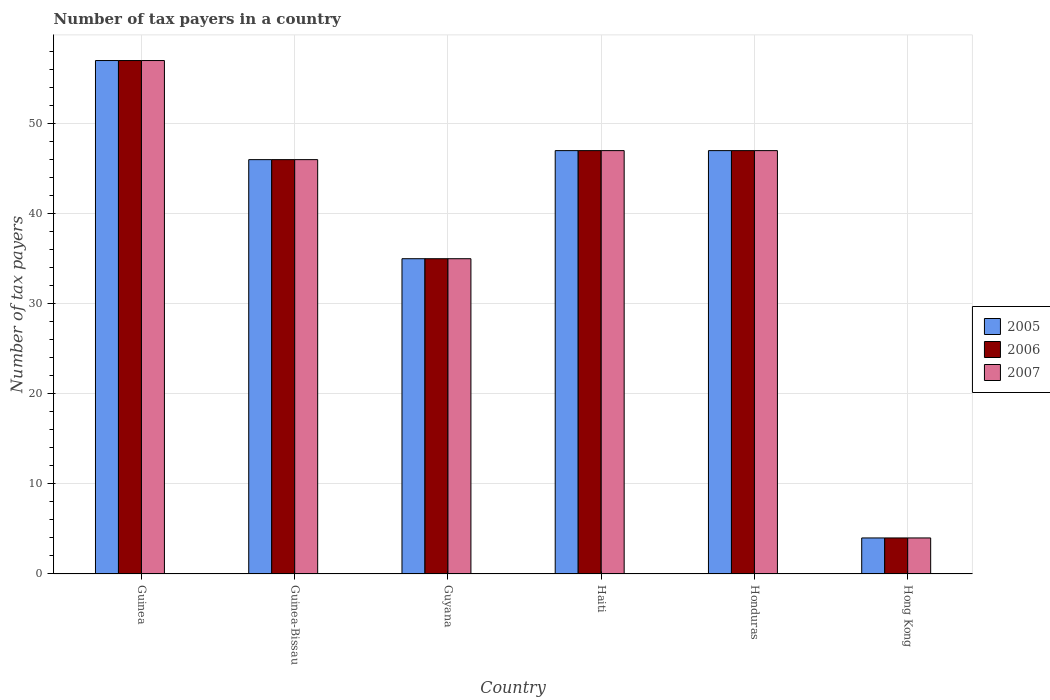Are the number of bars per tick equal to the number of legend labels?
Provide a succinct answer. Yes. Are the number of bars on each tick of the X-axis equal?
Provide a succinct answer. Yes. How many bars are there on the 2nd tick from the left?
Your answer should be compact. 3. How many bars are there on the 5th tick from the right?
Your answer should be compact. 3. What is the label of the 4th group of bars from the left?
Keep it short and to the point. Haiti. In which country was the number of tax payers in in 2007 maximum?
Keep it short and to the point. Guinea. In which country was the number of tax payers in in 2007 minimum?
Your response must be concise. Hong Kong. What is the total number of tax payers in in 2006 in the graph?
Give a very brief answer. 236. What is the difference between the number of tax payers in in 2006 in Honduras and that in Hong Kong?
Keep it short and to the point. 43. What is the difference between the number of tax payers in in 2006 in Honduras and the number of tax payers in in 2007 in Guyana?
Offer a terse response. 12. What is the average number of tax payers in in 2005 per country?
Your answer should be very brief. 39.33. What is the ratio of the number of tax payers in in 2007 in Guinea-Bissau to that in Haiti?
Your answer should be compact. 0.98. Is the number of tax payers in in 2005 in Guinea less than that in Hong Kong?
Ensure brevity in your answer.  No. Is the difference between the number of tax payers in in 2006 in Honduras and Hong Kong greater than the difference between the number of tax payers in in 2007 in Honduras and Hong Kong?
Provide a succinct answer. No. What is the difference between the highest and the lowest number of tax payers in in 2007?
Offer a very short reply. 53. Is the sum of the number of tax payers in in 2005 in Haiti and Honduras greater than the maximum number of tax payers in in 2007 across all countries?
Provide a succinct answer. Yes. What does the 2nd bar from the right in Hong Kong represents?
Ensure brevity in your answer.  2006. Is it the case that in every country, the sum of the number of tax payers in in 2006 and number of tax payers in in 2005 is greater than the number of tax payers in in 2007?
Your answer should be very brief. Yes. Are all the bars in the graph horizontal?
Offer a very short reply. No. How many countries are there in the graph?
Ensure brevity in your answer.  6. Are the values on the major ticks of Y-axis written in scientific E-notation?
Provide a short and direct response. No. Does the graph contain any zero values?
Offer a very short reply. No. Where does the legend appear in the graph?
Ensure brevity in your answer.  Center right. How are the legend labels stacked?
Ensure brevity in your answer.  Vertical. What is the title of the graph?
Your answer should be very brief. Number of tax payers in a country. What is the label or title of the Y-axis?
Offer a terse response. Number of tax payers. What is the Number of tax payers in 2006 in Guinea?
Make the answer very short. 57. What is the Number of tax payers in 2007 in Guinea?
Provide a succinct answer. 57. What is the Number of tax payers in 2005 in Guinea-Bissau?
Provide a short and direct response. 46. What is the Number of tax payers in 2006 in Guyana?
Ensure brevity in your answer.  35. What is the Number of tax payers of 2006 in Haiti?
Offer a very short reply. 47. What is the Number of tax payers of 2007 in Haiti?
Ensure brevity in your answer.  47. What is the Number of tax payers of 2005 in Honduras?
Offer a very short reply. 47. What is the Number of tax payers of 2006 in Honduras?
Your answer should be compact. 47. What is the Number of tax payers in 2007 in Honduras?
Ensure brevity in your answer.  47. What is the Number of tax payers of 2006 in Hong Kong?
Give a very brief answer. 4. What is the Number of tax payers of 2007 in Hong Kong?
Make the answer very short. 4. Across all countries, what is the maximum Number of tax payers of 2005?
Ensure brevity in your answer.  57. Across all countries, what is the maximum Number of tax payers in 2006?
Make the answer very short. 57. Across all countries, what is the minimum Number of tax payers in 2005?
Provide a succinct answer. 4. What is the total Number of tax payers in 2005 in the graph?
Provide a succinct answer. 236. What is the total Number of tax payers in 2006 in the graph?
Offer a terse response. 236. What is the total Number of tax payers of 2007 in the graph?
Make the answer very short. 236. What is the difference between the Number of tax payers in 2005 in Guinea and that in Guinea-Bissau?
Your answer should be very brief. 11. What is the difference between the Number of tax payers of 2005 in Guinea and that in Guyana?
Keep it short and to the point. 22. What is the difference between the Number of tax payers in 2006 in Guinea and that in Guyana?
Give a very brief answer. 22. What is the difference between the Number of tax payers in 2007 in Guinea and that in Guyana?
Your answer should be compact. 22. What is the difference between the Number of tax payers in 2006 in Guinea and that in Haiti?
Keep it short and to the point. 10. What is the difference between the Number of tax payers in 2005 in Guinea and that in Honduras?
Provide a succinct answer. 10. What is the difference between the Number of tax payers of 2006 in Guinea and that in Honduras?
Your response must be concise. 10. What is the difference between the Number of tax payers in 2005 in Guinea-Bissau and that in Guyana?
Your answer should be compact. 11. What is the difference between the Number of tax payers in 2007 in Guinea-Bissau and that in Guyana?
Make the answer very short. 11. What is the difference between the Number of tax payers in 2006 in Guinea-Bissau and that in Haiti?
Offer a terse response. -1. What is the difference between the Number of tax payers in 2005 in Guinea-Bissau and that in Honduras?
Offer a very short reply. -1. What is the difference between the Number of tax payers of 2006 in Guinea-Bissau and that in Honduras?
Offer a terse response. -1. What is the difference between the Number of tax payers in 2007 in Guinea-Bissau and that in Honduras?
Offer a terse response. -1. What is the difference between the Number of tax payers of 2005 in Guyana and that in Honduras?
Make the answer very short. -12. What is the difference between the Number of tax payers in 2006 in Guyana and that in Honduras?
Offer a terse response. -12. What is the difference between the Number of tax payers in 2005 in Guyana and that in Hong Kong?
Your answer should be very brief. 31. What is the difference between the Number of tax payers of 2007 in Guyana and that in Hong Kong?
Your answer should be compact. 31. What is the difference between the Number of tax payers in 2005 in Haiti and that in Honduras?
Ensure brevity in your answer.  0. What is the difference between the Number of tax payers of 2007 in Haiti and that in Hong Kong?
Ensure brevity in your answer.  43. What is the difference between the Number of tax payers in 2005 in Honduras and that in Hong Kong?
Keep it short and to the point. 43. What is the difference between the Number of tax payers of 2006 in Honduras and that in Hong Kong?
Keep it short and to the point. 43. What is the difference between the Number of tax payers of 2007 in Honduras and that in Hong Kong?
Offer a very short reply. 43. What is the difference between the Number of tax payers in 2006 in Guinea and the Number of tax payers in 2007 in Guinea-Bissau?
Offer a very short reply. 11. What is the difference between the Number of tax payers in 2005 in Guinea and the Number of tax payers in 2006 in Haiti?
Offer a terse response. 10. What is the difference between the Number of tax payers of 2006 in Guinea and the Number of tax payers of 2007 in Haiti?
Offer a very short reply. 10. What is the difference between the Number of tax payers in 2005 in Guinea and the Number of tax payers in 2006 in Hong Kong?
Offer a very short reply. 53. What is the difference between the Number of tax payers in 2006 in Guinea-Bissau and the Number of tax payers in 2007 in Guyana?
Offer a terse response. 11. What is the difference between the Number of tax payers of 2005 in Guinea-Bissau and the Number of tax payers of 2007 in Haiti?
Keep it short and to the point. -1. What is the difference between the Number of tax payers of 2006 in Guinea-Bissau and the Number of tax payers of 2007 in Haiti?
Offer a terse response. -1. What is the difference between the Number of tax payers of 2005 in Guinea-Bissau and the Number of tax payers of 2006 in Honduras?
Make the answer very short. -1. What is the difference between the Number of tax payers of 2005 in Guinea-Bissau and the Number of tax payers of 2007 in Honduras?
Give a very brief answer. -1. What is the difference between the Number of tax payers of 2005 in Guinea-Bissau and the Number of tax payers of 2006 in Hong Kong?
Your response must be concise. 42. What is the difference between the Number of tax payers of 2005 in Haiti and the Number of tax payers of 2006 in Honduras?
Your response must be concise. 0. What is the difference between the Number of tax payers in 2006 in Haiti and the Number of tax payers in 2007 in Hong Kong?
Offer a very short reply. 43. What is the difference between the Number of tax payers of 2005 in Honduras and the Number of tax payers of 2006 in Hong Kong?
Give a very brief answer. 43. What is the difference between the Number of tax payers in 2005 in Honduras and the Number of tax payers in 2007 in Hong Kong?
Offer a terse response. 43. What is the difference between the Number of tax payers of 2006 in Honduras and the Number of tax payers of 2007 in Hong Kong?
Offer a very short reply. 43. What is the average Number of tax payers of 2005 per country?
Offer a terse response. 39.33. What is the average Number of tax payers in 2006 per country?
Your answer should be compact. 39.33. What is the average Number of tax payers of 2007 per country?
Your response must be concise. 39.33. What is the difference between the Number of tax payers of 2005 and Number of tax payers of 2006 in Guinea-Bissau?
Make the answer very short. 0. What is the difference between the Number of tax payers of 2005 and Number of tax payers of 2007 in Guyana?
Provide a succinct answer. 0. What is the difference between the Number of tax payers of 2005 and Number of tax payers of 2006 in Haiti?
Ensure brevity in your answer.  0. What is the difference between the Number of tax payers of 2006 and Number of tax payers of 2007 in Haiti?
Provide a succinct answer. 0. What is the difference between the Number of tax payers of 2006 and Number of tax payers of 2007 in Honduras?
Keep it short and to the point. 0. What is the difference between the Number of tax payers of 2005 and Number of tax payers of 2007 in Hong Kong?
Your answer should be compact. 0. What is the ratio of the Number of tax payers in 2005 in Guinea to that in Guinea-Bissau?
Your answer should be compact. 1.24. What is the ratio of the Number of tax payers in 2006 in Guinea to that in Guinea-Bissau?
Offer a terse response. 1.24. What is the ratio of the Number of tax payers of 2007 in Guinea to that in Guinea-Bissau?
Ensure brevity in your answer.  1.24. What is the ratio of the Number of tax payers in 2005 in Guinea to that in Guyana?
Provide a short and direct response. 1.63. What is the ratio of the Number of tax payers of 2006 in Guinea to that in Guyana?
Provide a short and direct response. 1.63. What is the ratio of the Number of tax payers of 2007 in Guinea to that in Guyana?
Your answer should be very brief. 1.63. What is the ratio of the Number of tax payers in 2005 in Guinea to that in Haiti?
Ensure brevity in your answer.  1.21. What is the ratio of the Number of tax payers of 2006 in Guinea to that in Haiti?
Keep it short and to the point. 1.21. What is the ratio of the Number of tax payers of 2007 in Guinea to that in Haiti?
Provide a short and direct response. 1.21. What is the ratio of the Number of tax payers in 2005 in Guinea to that in Honduras?
Your answer should be very brief. 1.21. What is the ratio of the Number of tax payers of 2006 in Guinea to that in Honduras?
Your answer should be very brief. 1.21. What is the ratio of the Number of tax payers in 2007 in Guinea to that in Honduras?
Provide a succinct answer. 1.21. What is the ratio of the Number of tax payers of 2005 in Guinea to that in Hong Kong?
Your answer should be very brief. 14.25. What is the ratio of the Number of tax payers in 2006 in Guinea to that in Hong Kong?
Provide a short and direct response. 14.25. What is the ratio of the Number of tax payers of 2007 in Guinea to that in Hong Kong?
Your answer should be compact. 14.25. What is the ratio of the Number of tax payers in 2005 in Guinea-Bissau to that in Guyana?
Provide a succinct answer. 1.31. What is the ratio of the Number of tax payers in 2006 in Guinea-Bissau to that in Guyana?
Make the answer very short. 1.31. What is the ratio of the Number of tax payers in 2007 in Guinea-Bissau to that in Guyana?
Ensure brevity in your answer.  1.31. What is the ratio of the Number of tax payers in 2005 in Guinea-Bissau to that in Haiti?
Offer a very short reply. 0.98. What is the ratio of the Number of tax payers in 2006 in Guinea-Bissau to that in Haiti?
Offer a terse response. 0.98. What is the ratio of the Number of tax payers of 2007 in Guinea-Bissau to that in Haiti?
Offer a very short reply. 0.98. What is the ratio of the Number of tax payers of 2005 in Guinea-Bissau to that in Honduras?
Ensure brevity in your answer.  0.98. What is the ratio of the Number of tax payers in 2006 in Guinea-Bissau to that in Honduras?
Your response must be concise. 0.98. What is the ratio of the Number of tax payers of 2007 in Guinea-Bissau to that in Honduras?
Offer a terse response. 0.98. What is the ratio of the Number of tax payers of 2006 in Guinea-Bissau to that in Hong Kong?
Make the answer very short. 11.5. What is the ratio of the Number of tax payers of 2007 in Guinea-Bissau to that in Hong Kong?
Ensure brevity in your answer.  11.5. What is the ratio of the Number of tax payers in 2005 in Guyana to that in Haiti?
Keep it short and to the point. 0.74. What is the ratio of the Number of tax payers in 2006 in Guyana to that in Haiti?
Offer a very short reply. 0.74. What is the ratio of the Number of tax payers of 2007 in Guyana to that in Haiti?
Offer a very short reply. 0.74. What is the ratio of the Number of tax payers of 2005 in Guyana to that in Honduras?
Offer a terse response. 0.74. What is the ratio of the Number of tax payers in 2006 in Guyana to that in Honduras?
Your response must be concise. 0.74. What is the ratio of the Number of tax payers in 2007 in Guyana to that in Honduras?
Ensure brevity in your answer.  0.74. What is the ratio of the Number of tax payers in 2005 in Guyana to that in Hong Kong?
Provide a succinct answer. 8.75. What is the ratio of the Number of tax payers in 2006 in Guyana to that in Hong Kong?
Provide a succinct answer. 8.75. What is the ratio of the Number of tax payers of 2007 in Guyana to that in Hong Kong?
Ensure brevity in your answer.  8.75. What is the ratio of the Number of tax payers of 2007 in Haiti to that in Honduras?
Your answer should be compact. 1. What is the ratio of the Number of tax payers in 2005 in Haiti to that in Hong Kong?
Your answer should be compact. 11.75. What is the ratio of the Number of tax payers of 2006 in Haiti to that in Hong Kong?
Make the answer very short. 11.75. What is the ratio of the Number of tax payers of 2007 in Haiti to that in Hong Kong?
Offer a very short reply. 11.75. What is the ratio of the Number of tax payers in 2005 in Honduras to that in Hong Kong?
Ensure brevity in your answer.  11.75. What is the ratio of the Number of tax payers in 2006 in Honduras to that in Hong Kong?
Keep it short and to the point. 11.75. What is the ratio of the Number of tax payers in 2007 in Honduras to that in Hong Kong?
Ensure brevity in your answer.  11.75. What is the difference between the highest and the second highest Number of tax payers of 2006?
Your response must be concise. 10. What is the difference between the highest and the second highest Number of tax payers in 2007?
Offer a terse response. 10. What is the difference between the highest and the lowest Number of tax payers in 2006?
Make the answer very short. 53. What is the difference between the highest and the lowest Number of tax payers in 2007?
Give a very brief answer. 53. 